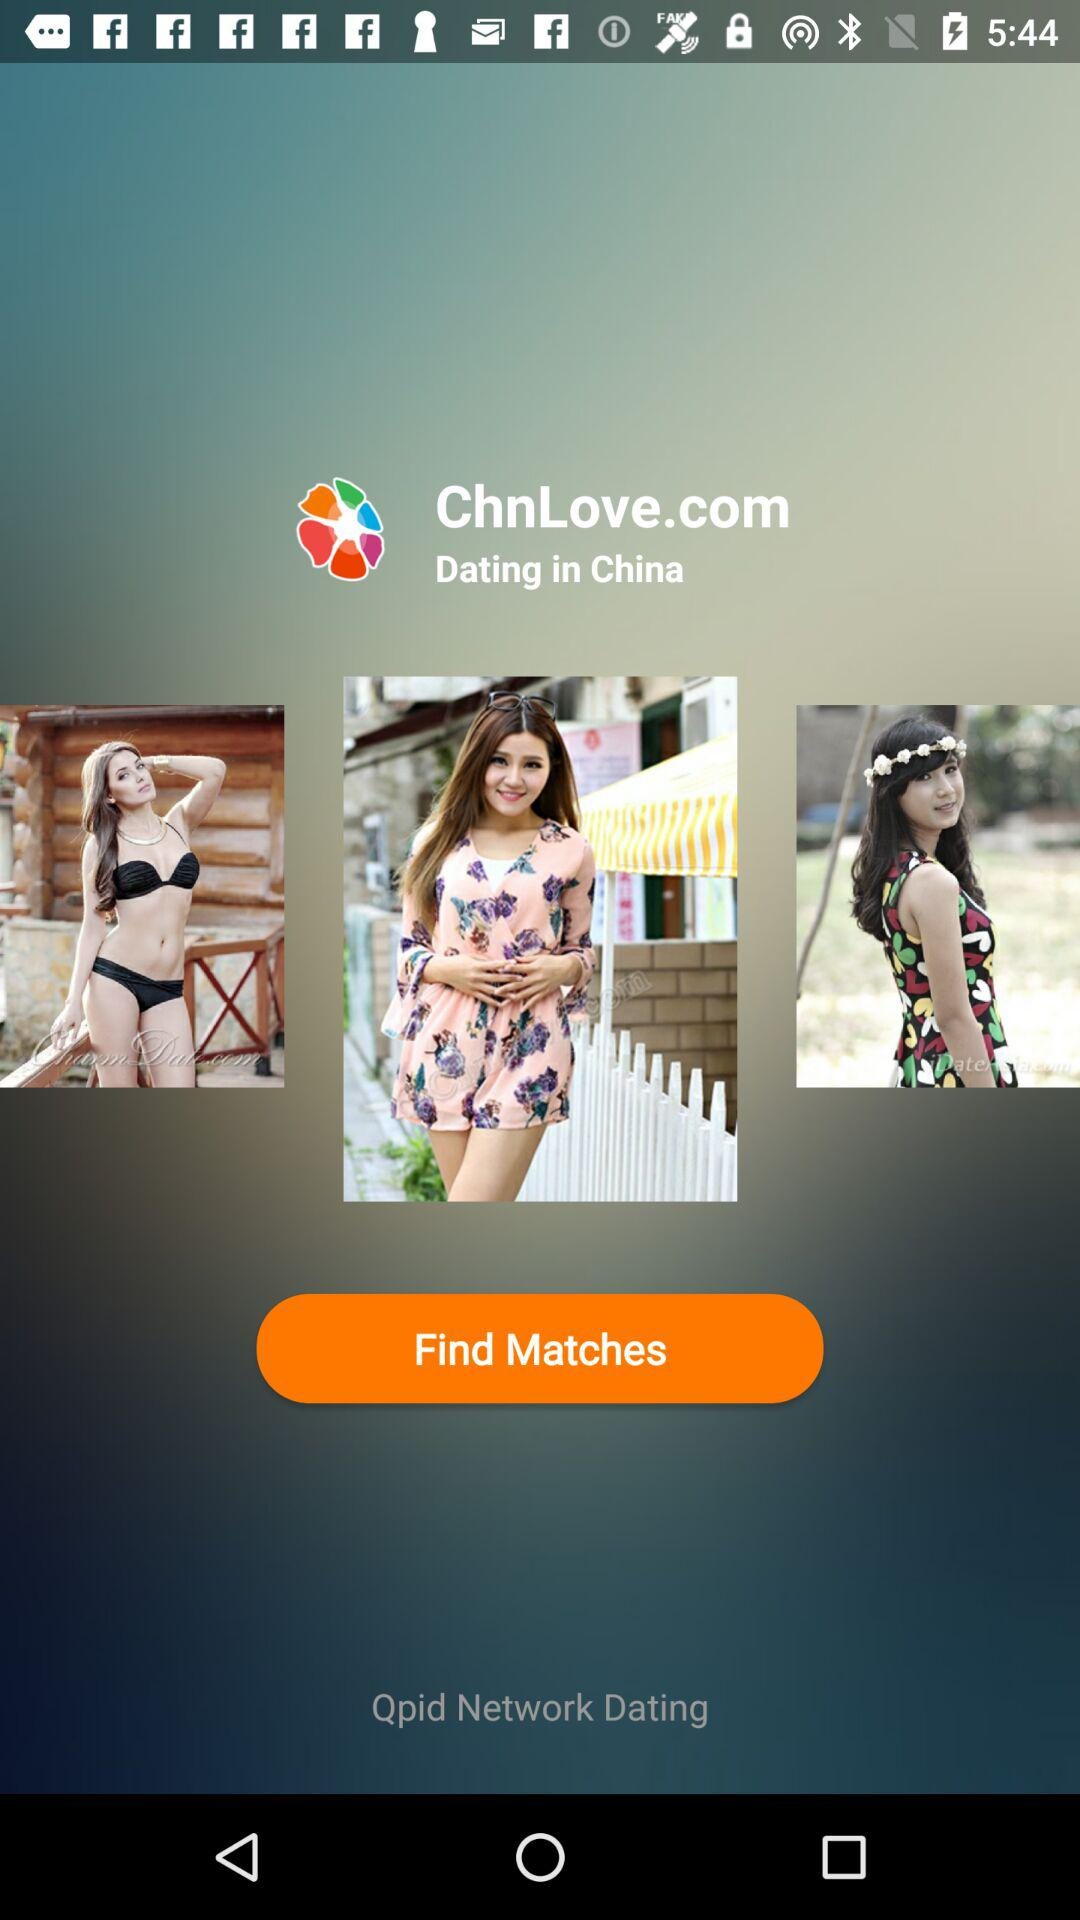How much is a full membership to the dating app?
When the provided information is insufficient, respond with <no answer>. <no answer> 